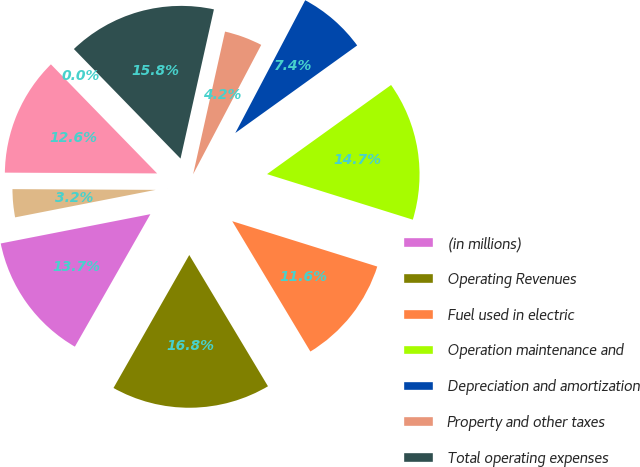Convert chart to OTSL. <chart><loc_0><loc_0><loc_500><loc_500><pie_chart><fcel>(in millions)<fcel>Operating Revenues<fcel>Fuel used in electric<fcel>Operation maintenance and<fcel>Depreciation and amortization<fcel>Property and other taxes<fcel>Total operating expenses<fcel>Gain (Loss) on Sales of Other<fcel>Operating Income<fcel>Other Income and Expenses net<nl><fcel>13.68%<fcel>16.84%<fcel>11.58%<fcel>14.74%<fcel>7.37%<fcel>4.21%<fcel>15.79%<fcel>0.0%<fcel>12.63%<fcel>3.16%<nl></chart> 